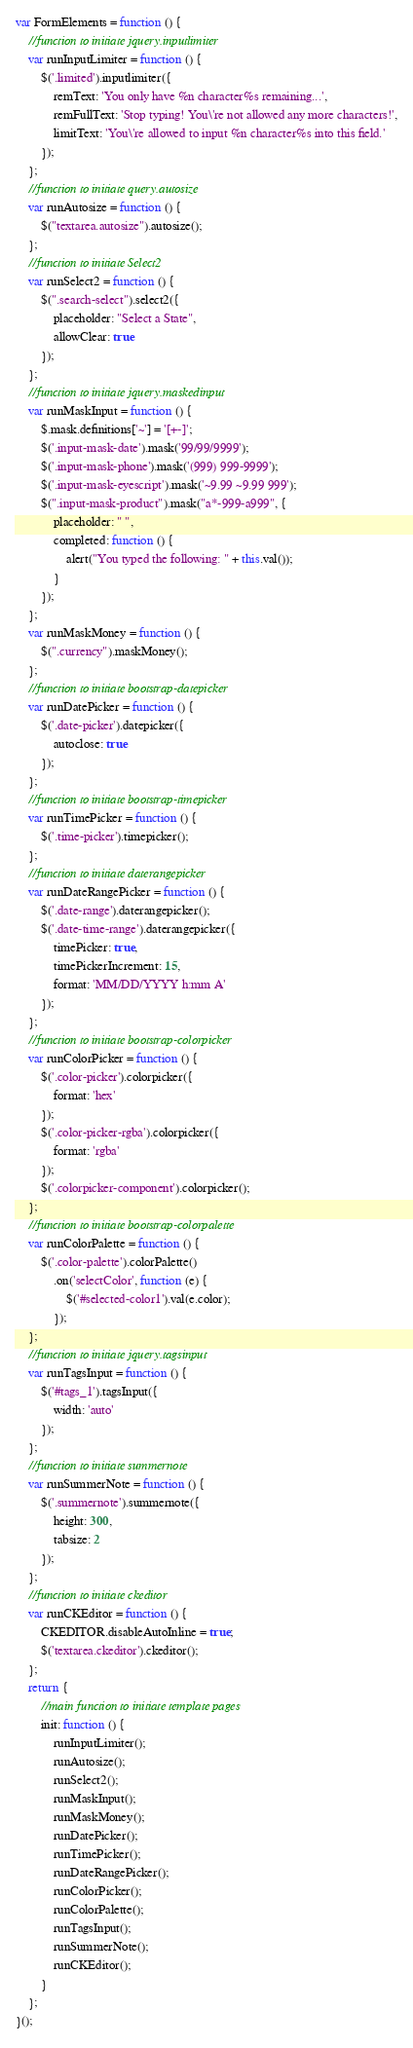<code> <loc_0><loc_0><loc_500><loc_500><_JavaScript_>var FormElements = function () {
    //function to initiate jquery.inputlimiter
    var runInputLimiter = function () {
        $('.limited').inputlimiter({
            remText: 'You only have %n character%s remaining...',
            remFullText: 'Stop typing! You\'re not allowed any more characters!',
            limitText: 'You\'re allowed to input %n character%s into this field.'
        });
    };
    //function to initiate query.autosize    
    var runAutosize = function () {
        $("textarea.autosize").autosize();
    };
    //function to initiate Select2
    var runSelect2 = function () {
        $(".search-select").select2({
            placeholder: "Select a State",
            allowClear: true
        });
    };
    //function to initiate jquery.maskedinput
    var runMaskInput = function () {
        $.mask.definitions['~'] = '[+-]';
        $('.input-mask-date').mask('99/99/9999');
        $('.input-mask-phone').mask('(999) 999-9999');
        $('.input-mask-eyescript').mask('~9.99 ~9.99 999');
        $(".input-mask-product").mask("a*-999-a999", {
            placeholder: " ",
            completed: function () {
                alert("You typed the following: " + this.val());
            }
        });
    };
    var runMaskMoney = function () {
        $(".currency").maskMoney();
    };
    //function to initiate bootstrap-datepicker
    var runDatePicker = function () {
        $('.date-picker').datepicker({
            autoclose: true
        });
    };
    //function to initiate bootstrap-timepicker
    var runTimePicker = function () {
        $('.time-picker').timepicker();
    };
    //function to initiate daterangepicker
    var runDateRangePicker = function () {
        $('.date-range').daterangepicker();
        $('.date-time-range').daterangepicker({
            timePicker: true,
            timePickerIncrement: 15,
            format: 'MM/DD/YYYY h:mm A'
        });
    };
    //function to initiate bootstrap-colorpicker
    var runColorPicker = function () {
        $('.color-picker').colorpicker({
            format: 'hex'
        });
        $('.color-picker-rgba').colorpicker({
            format: 'rgba'
        });
        $('.colorpicker-component').colorpicker();
    };
    //function to initiate bootstrap-colorpalette
    var runColorPalette = function () {
        $('.color-palette').colorPalette()
            .on('selectColor', function (e) {
                $('#selected-color1').val(e.color);
            });
    };
    //function to initiate jquery.tagsinput
    var runTagsInput = function () {
        $('#tags_1').tagsInput({
            width: 'auto'
        });
    };
    //function to initiate summernote
    var runSummerNote = function () {
        $('.summernote').summernote({
            height: 300,
            tabsize: 2
        });
    };
    //function to initiate ckeditor
    var runCKEditor = function () {
        CKEDITOR.disableAutoInline = true;
        $('textarea.ckeditor').ckeditor();
    };
    return {
        //main function to initiate template pages
        init: function () {
            runInputLimiter();
            runAutosize();
            runSelect2();
            runMaskInput();
            runMaskMoney();
            runDatePicker();
            runTimePicker();
            runDateRangePicker();
            runColorPicker();
            runColorPalette();
            runTagsInput();
            runSummerNote();
            runCKEditor();
        }
    };
}();</code> 